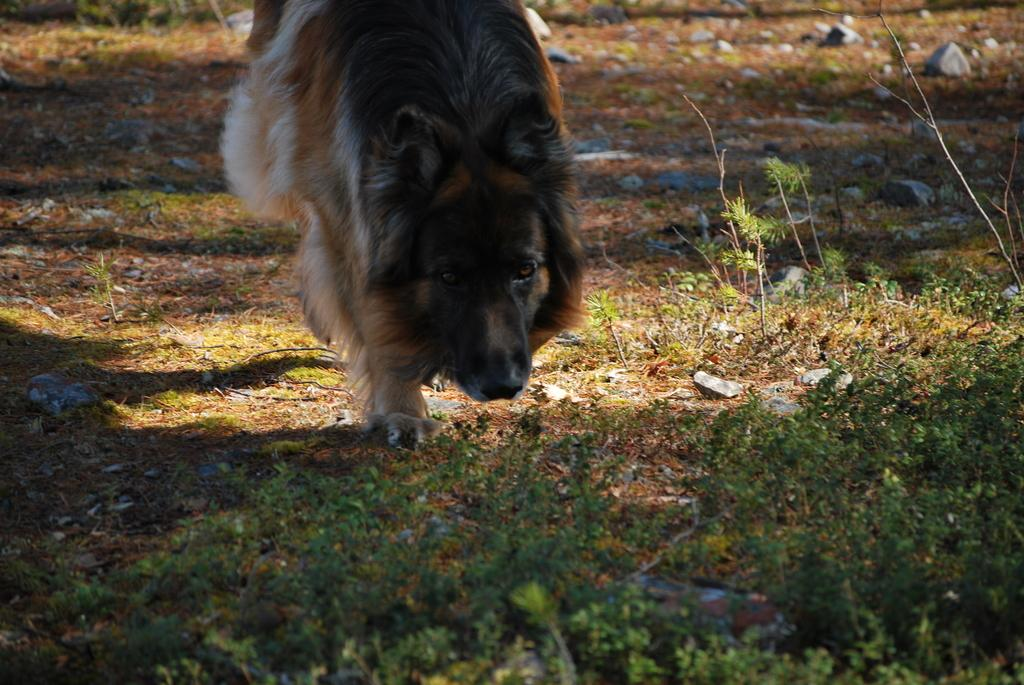What type of animal is present in the image? There is a dog in the image. What can be seen at the bottom of the image? There are plants at the bottom of the image. What is on the ground in the image? There are stones on the ground in the image. What type of payment is being made in the image? There is no payment being made in the image; it features a dog, plants, and stones. What type of linen is draped over the dog in the image? There is no linen present in the image, and the dog is not covered by any fabric. 